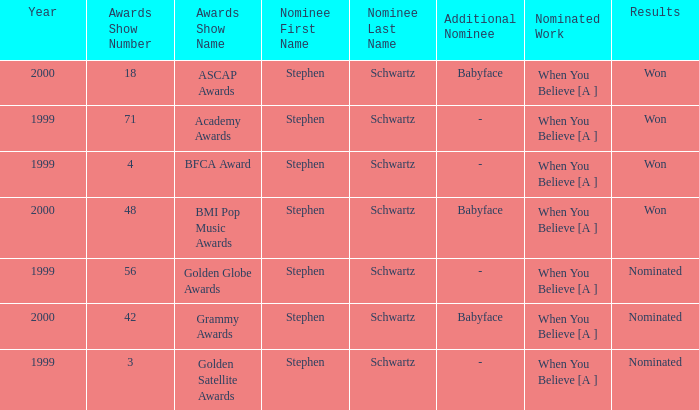What was the results of the 71st Academy Awards show? Won. 